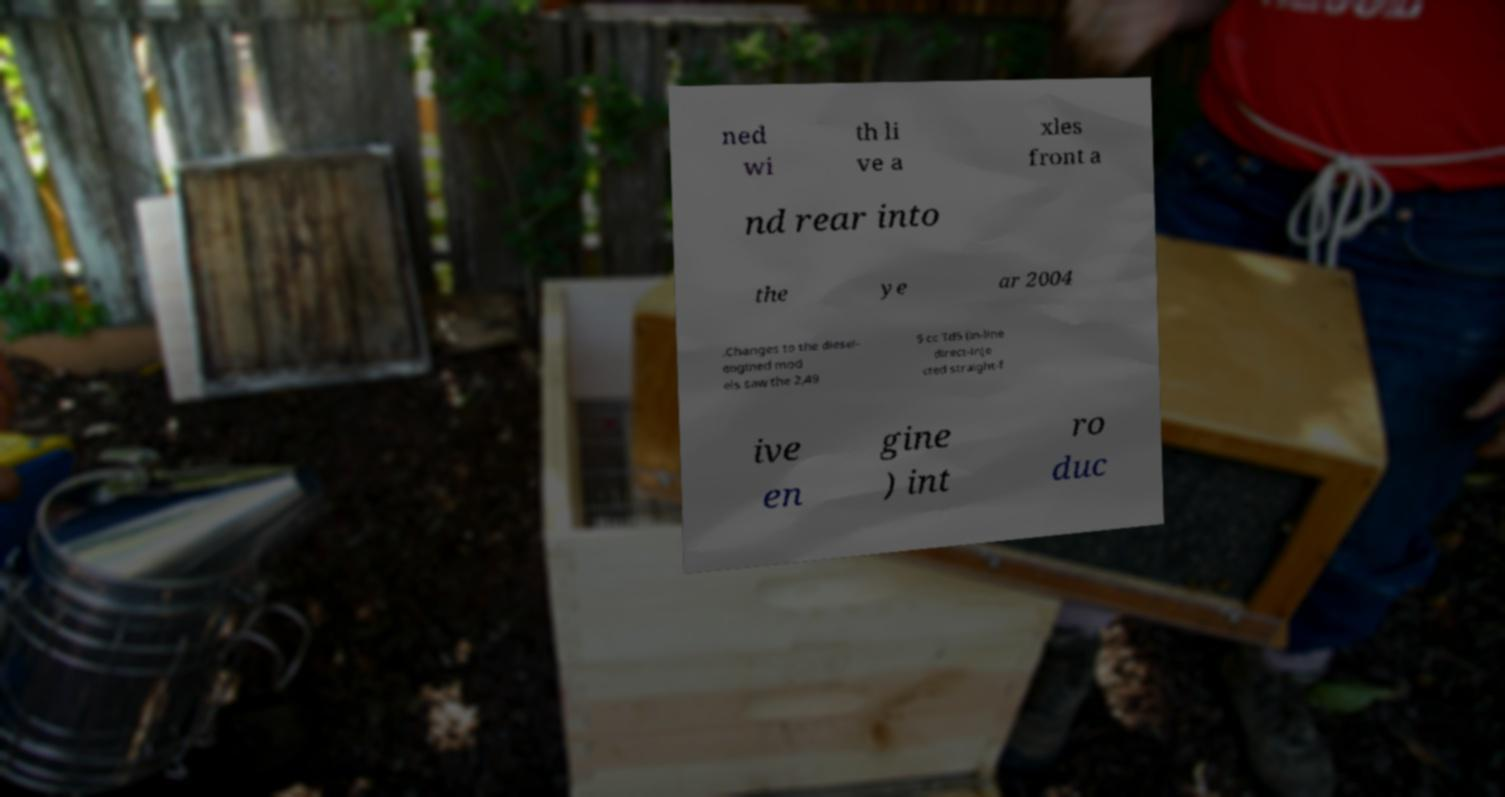Please identify and transcribe the text found in this image. ned wi th li ve a xles front a nd rear into the ye ar 2004 .Changes to the diesel- engined mod els saw the 2,49 5 cc Td5 (in-line direct-inje cted straight-f ive en gine ) int ro duc 